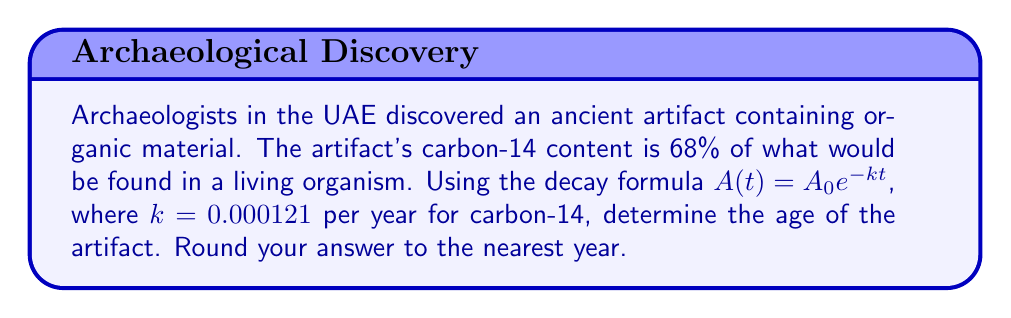Show me your answer to this math problem. Let's approach this step-by-step:

1) The decay formula is $A(t) = A_0 e^{-kt}$, where:
   $A(t)$ is the amount remaining after time $t$
   $A_0$ is the initial amount
   $k$ is the decay constant
   $t$ is time

2) We're told that 68% of the original amount remains, so:
   $\frac{A(t)}{A_0} = 0.68$

3) Substituting this into the decay formula:
   $0.68 = e^{-kt}$

4) Taking the natural log of both sides:
   $\ln(0.68) = -kt$

5) Solving for $t$:
   $t = -\frac{\ln(0.68)}{k}$

6) We know $k = 0.000121$ per year, so:
   $t = -\frac{\ln(0.68)}{0.000121}$

7) Calculating:
   $t \approx 3170.96$ years

8) Rounding to the nearest year:
   $t \approx 3171$ years
Answer: 3171 years 